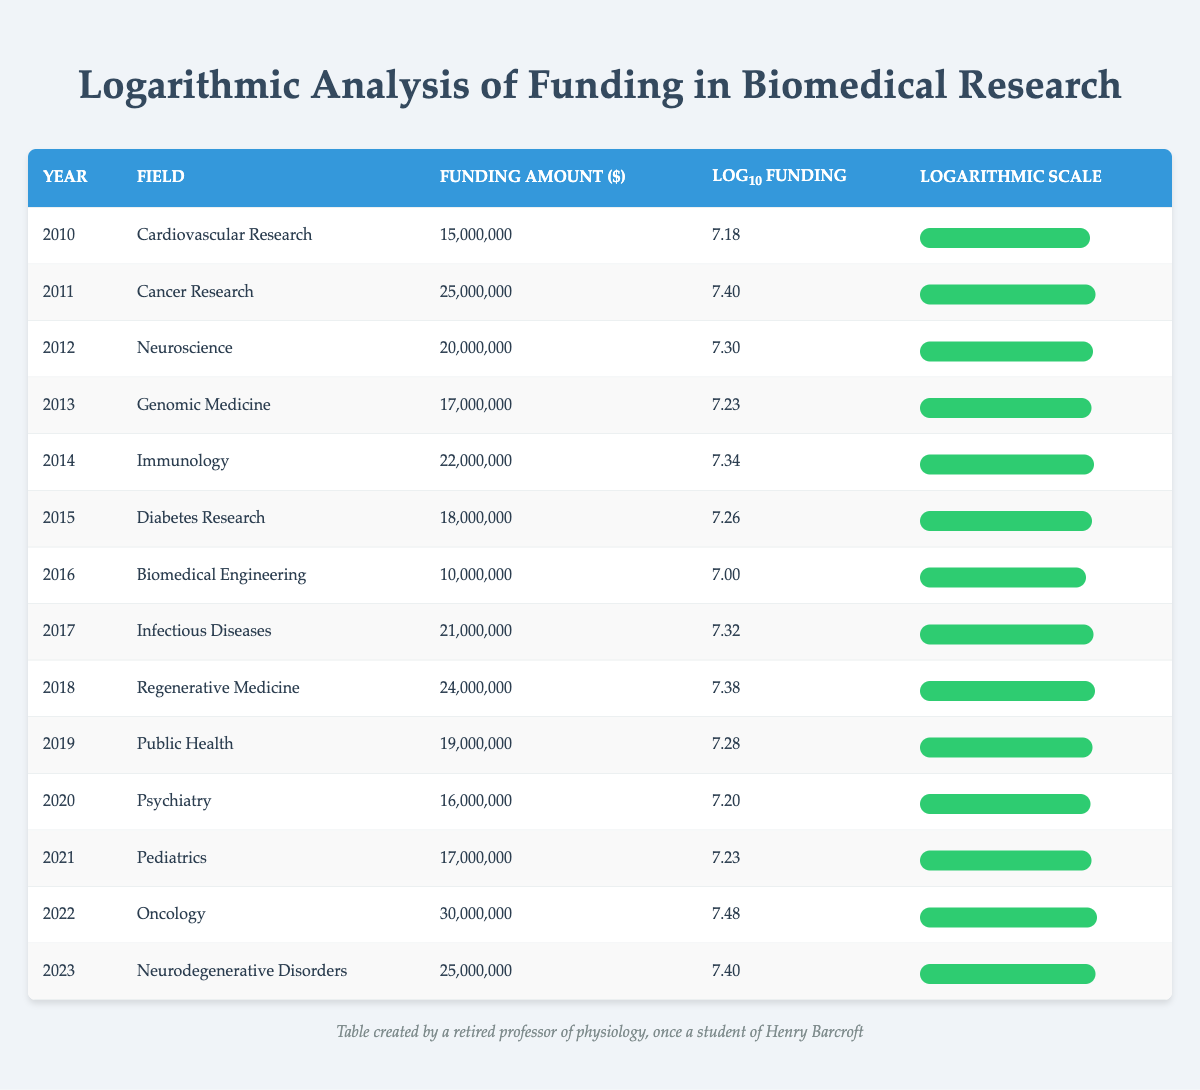What was the funding amount for Cancer Research in 2011? The table indicates that Cancer Research had a funding amount of 25,000,000 in the year 2011.
Answer: 25,000,000 Which field received the highest funding in 2022? Reviewing the table, Oncology received the highest funding amount of 30,000,000 in 2022.
Answer: Oncology What is the log10 funding value for Regenerative Medicine in 2018? The table shows that Regenerative Medicine had a log10 funding value of 7.38 in 2018.
Answer: 7.38 In which year did Diabetes Research receive less funding than Infectious Diseases? According to the table, Diabetes Research received 18,000,000 in 2015, whereas Infectious Diseases received 21,000,000 in 2017, meaning Diabetes Research received less funding in 2015 compared to the funding for Infectious Diseases.
Answer: 2015 What is the average funding amount across all years provided for Neuroscience, Oncology, and Psychiatry? The funding amounts for the specified fields are: Neuroscience (20,000,000 in 2012), Oncology (30,000,000 in 2022), and Psychiatry (16,000,000 in 2020). The sum is 20,000,000 + 30,000,000 + 16,000,000 = 66,000,000. This total divided by 3 years gives an average of 66,000,000 / 3 = 22,000,000.
Answer: 22,000,000 Did the funding for Neurodegenerative Disorders in 2023 exceed the funding for Diabetes Research in 2015? The table states that Neurodegenerative Disorders had a funding amount of 25,000,000 in 2023 and Diabetes Research had 18,000,000 in 2015. Since 25,000,000 is greater than 18,000,000, the funding for Neurodegenerative Disorders did exceed that of Diabetes Research.
Answer: Yes How much more funding did Oncology receive in 2022 compared to Cardiovascular Research in 2010? The table shows that Oncology received 30,000,000 in 2022 and Cardiovascular Research received 15,000,000 in 2010. The difference in funding is calculated as 30,000,000 - 15,000,000 = 15,000,000.
Answer: 15,000,000 Which field's funding has the smallest logarithmic value, and what is that value? Reviewing the log10 values in the table, Biomedical Engineering has the smallest log10 funding value of 7.00 in 2016.
Answer: Biomedical Engineering, 7.00 What was the total amount of funding for all fields in 2017? Referring to the table, the only funding amount listed in 2017 is for Infectious Diseases, which received 21,000,000. So, the total for that year is simply 21,000,000.
Answer: 21,000,000 